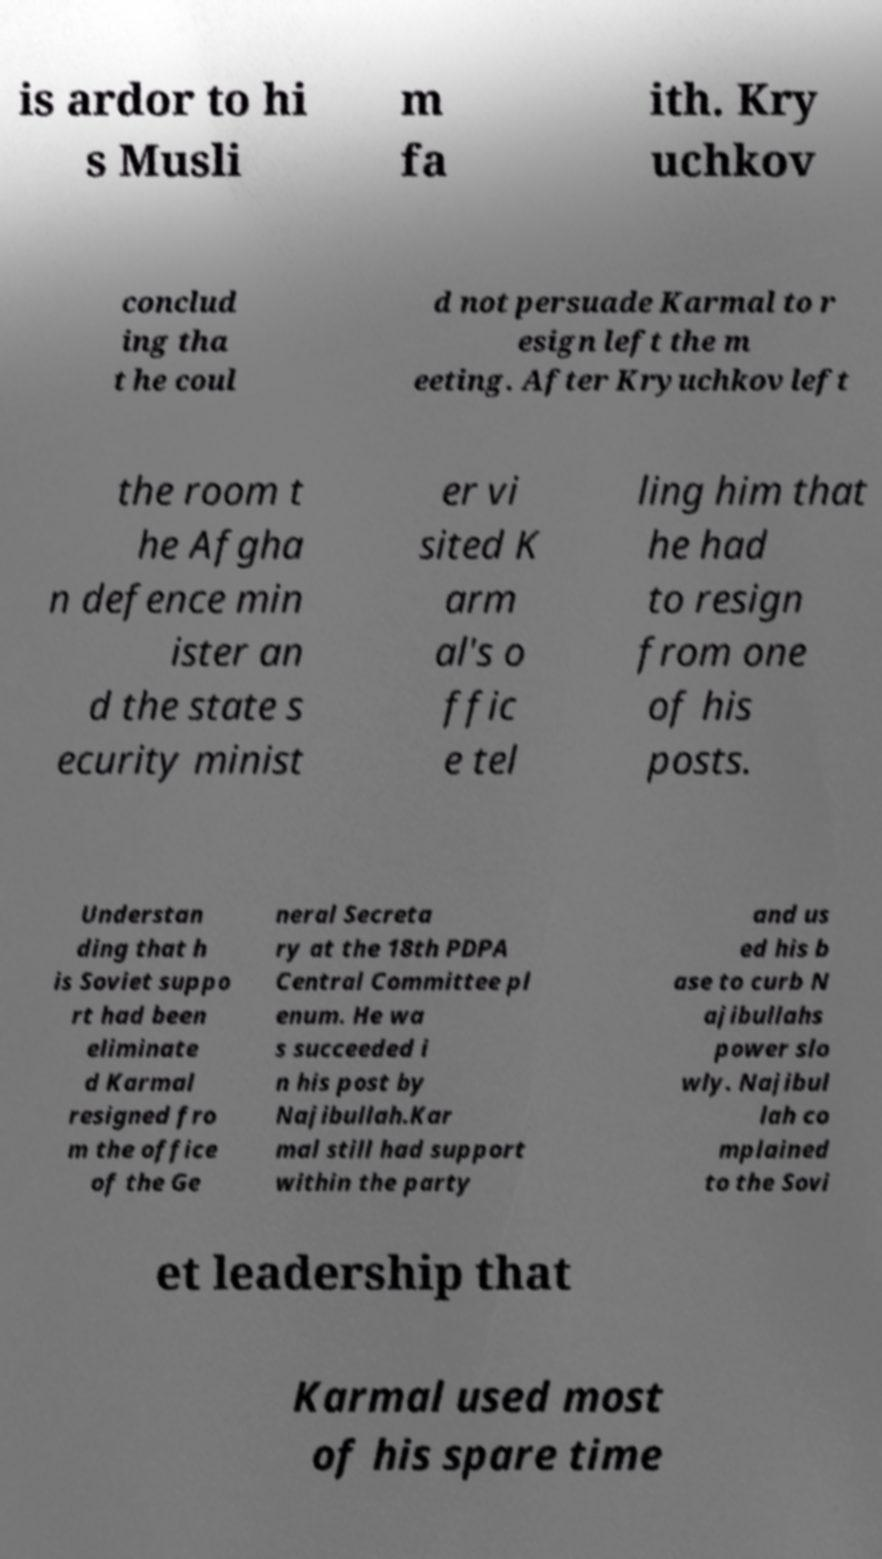I need the written content from this picture converted into text. Can you do that? is ardor to hi s Musli m fa ith. Kry uchkov conclud ing tha t he coul d not persuade Karmal to r esign left the m eeting. After Kryuchkov left the room t he Afgha n defence min ister an d the state s ecurity minist er vi sited K arm al's o ffic e tel ling him that he had to resign from one of his posts. Understan ding that h is Soviet suppo rt had been eliminate d Karmal resigned fro m the office of the Ge neral Secreta ry at the 18th PDPA Central Committee pl enum. He wa s succeeded i n his post by Najibullah.Kar mal still had support within the party and us ed his b ase to curb N ajibullahs power slo wly. Najibul lah co mplained to the Sovi et leadership that Karmal used most of his spare time 